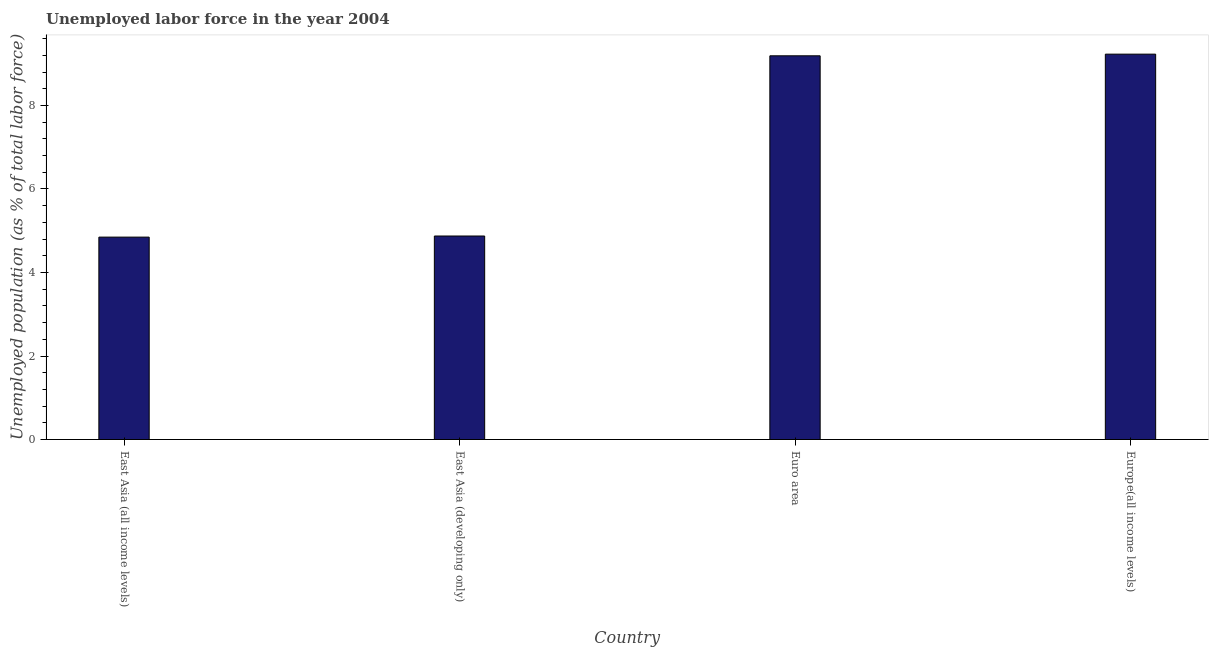Does the graph contain any zero values?
Offer a very short reply. No. What is the title of the graph?
Your answer should be very brief. Unemployed labor force in the year 2004. What is the label or title of the X-axis?
Make the answer very short. Country. What is the label or title of the Y-axis?
Provide a short and direct response. Unemployed population (as % of total labor force). What is the total unemployed population in East Asia (all income levels)?
Your answer should be very brief. 4.85. Across all countries, what is the maximum total unemployed population?
Provide a succinct answer. 9.23. Across all countries, what is the minimum total unemployed population?
Ensure brevity in your answer.  4.85. In which country was the total unemployed population maximum?
Your response must be concise. Europe(all income levels). In which country was the total unemployed population minimum?
Your answer should be very brief. East Asia (all income levels). What is the sum of the total unemployed population?
Ensure brevity in your answer.  28.14. What is the difference between the total unemployed population in East Asia (all income levels) and Europe(all income levels)?
Give a very brief answer. -4.38. What is the average total unemployed population per country?
Give a very brief answer. 7.03. What is the median total unemployed population?
Make the answer very short. 7.03. What is the ratio of the total unemployed population in East Asia (developing only) to that in Euro area?
Give a very brief answer. 0.53. Is the difference between the total unemployed population in East Asia (all income levels) and East Asia (developing only) greater than the difference between any two countries?
Your answer should be very brief. No. Is the sum of the total unemployed population in East Asia (all income levels) and Europe(all income levels) greater than the maximum total unemployed population across all countries?
Your response must be concise. Yes. What is the difference between the highest and the lowest total unemployed population?
Give a very brief answer. 4.38. In how many countries, is the total unemployed population greater than the average total unemployed population taken over all countries?
Keep it short and to the point. 2. How many bars are there?
Give a very brief answer. 4. Are all the bars in the graph horizontal?
Offer a terse response. No. What is the difference between two consecutive major ticks on the Y-axis?
Make the answer very short. 2. What is the Unemployed population (as % of total labor force) in East Asia (all income levels)?
Make the answer very short. 4.85. What is the Unemployed population (as % of total labor force) in East Asia (developing only)?
Offer a terse response. 4.87. What is the Unemployed population (as % of total labor force) in Euro area?
Your answer should be very brief. 9.19. What is the Unemployed population (as % of total labor force) in Europe(all income levels)?
Keep it short and to the point. 9.23. What is the difference between the Unemployed population (as % of total labor force) in East Asia (all income levels) and East Asia (developing only)?
Your answer should be compact. -0.03. What is the difference between the Unemployed population (as % of total labor force) in East Asia (all income levels) and Euro area?
Give a very brief answer. -4.34. What is the difference between the Unemployed population (as % of total labor force) in East Asia (all income levels) and Europe(all income levels)?
Give a very brief answer. -4.38. What is the difference between the Unemployed population (as % of total labor force) in East Asia (developing only) and Euro area?
Your answer should be compact. -4.32. What is the difference between the Unemployed population (as % of total labor force) in East Asia (developing only) and Europe(all income levels)?
Keep it short and to the point. -4.35. What is the difference between the Unemployed population (as % of total labor force) in Euro area and Europe(all income levels)?
Offer a very short reply. -0.04. What is the ratio of the Unemployed population (as % of total labor force) in East Asia (all income levels) to that in East Asia (developing only)?
Offer a very short reply. 0.99. What is the ratio of the Unemployed population (as % of total labor force) in East Asia (all income levels) to that in Euro area?
Offer a terse response. 0.53. What is the ratio of the Unemployed population (as % of total labor force) in East Asia (all income levels) to that in Europe(all income levels)?
Keep it short and to the point. 0.53. What is the ratio of the Unemployed population (as % of total labor force) in East Asia (developing only) to that in Euro area?
Your response must be concise. 0.53. What is the ratio of the Unemployed population (as % of total labor force) in East Asia (developing only) to that in Europe(all income levels)?
Give a very brief answer. 0.53. What is the ratio of the Unemployed population (as % of total labor force) in Euro area to that in Europe(all income levels)?
Your answer should be very brief. 1. 